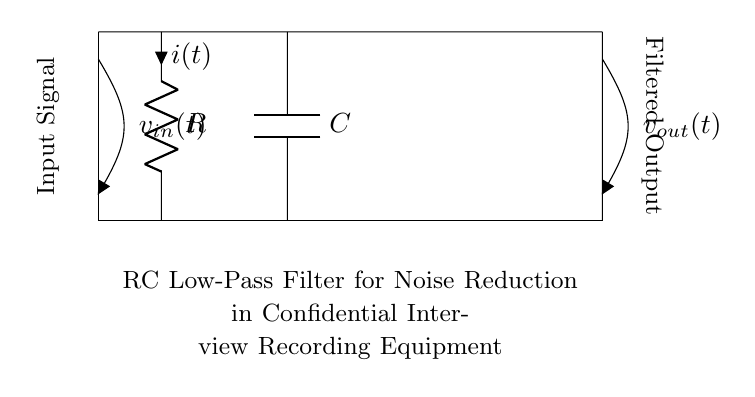What is the input signal in this circuit? The input signal is represented as \( v_{in}(t) \), which is connected at the left side of the circuit. It indicates the voltage applied to the RC filter.
Answer: v in(t) What is the output of the circuit? The output of the circuit is represented as \( v_{out}(t) \), which is found at the right side of the circuit where the filtered voltage is measured after passing through the RC filter.
Answer: v out(t) What is the value of the resistor? The resistor is symbolized by \( R \), but the specific value isn't provided in the diagram. It indicates a generic resistance used for the circuit function.
Answer: R What is the value of the capacitor? The capacitor is represented as \( C \), similar to the resistor, the exact value is not provided in the diagram, indicating a generic capacitance utilized in the circuit for filtering.
Answer: C What is the function of this circuit? The circuit functions as a low-pass filter, which allows low-frequency signals to pass while attenuating high-frequency noise, particularly useful for audio recording equipment in confidential interviews.
Answer: Low-pass filter How does a low-pass filter affect noise reduction? A low-pass filter reduces high-frequency noise by using the resistor and capacitor in combination to determine the cutoff frequency, below which signals are allowed to pass, effectively reducing unwanted high-frequency noise in audio recordings.
Answer: By attenuating high-frequency noise What is the significance of using an RC circuit in audio recording for confidential interviews? The RC circuit is significant in this context as it helps maintain audio clarity by filtering out noise, ensuring that confidential conversations remain clear and intelligible, thus protecting sensitive information.
Answer: Noise reduction 